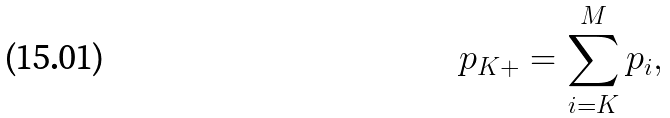Convert formula to latex. <formula><loc_0><loc_0><loc_500><loc_500>p _ { K + } = \sum _ { i = K } ^ { M } p _ { i } ,</formula> 